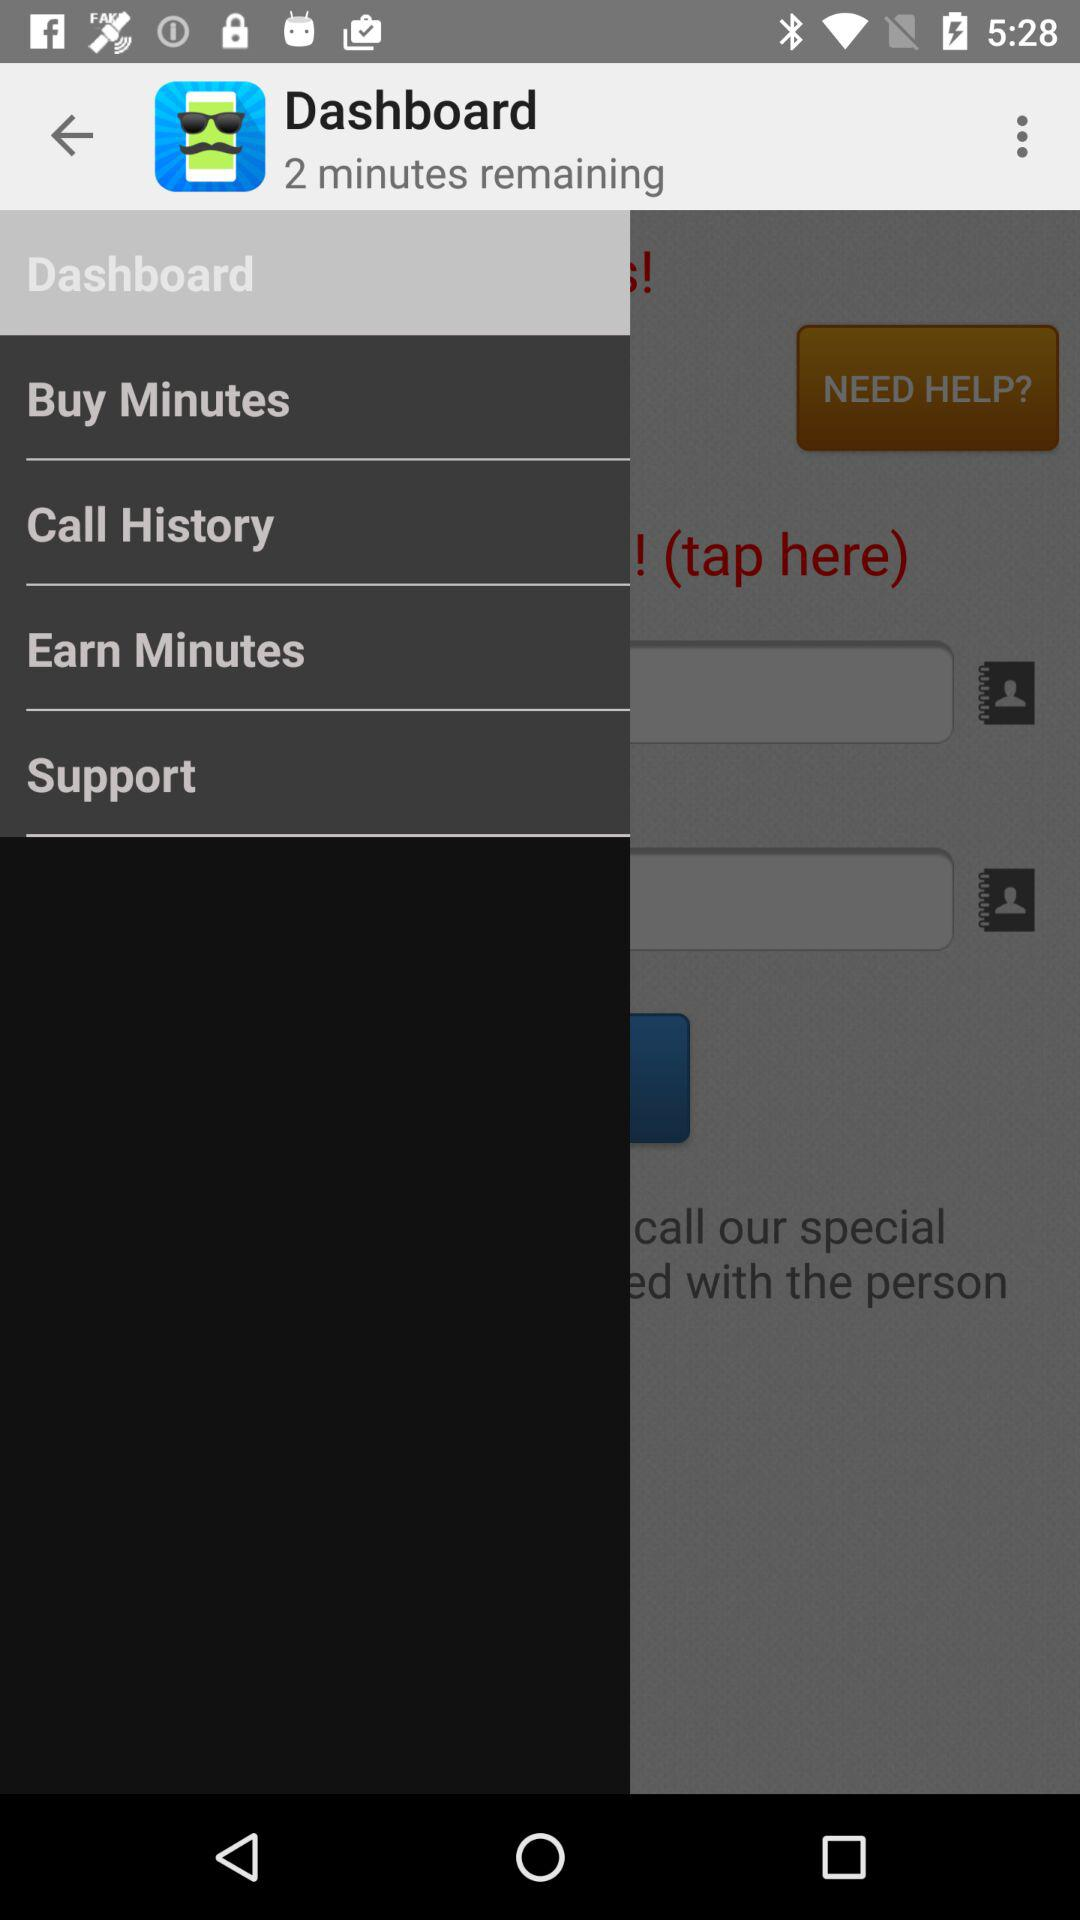What is the remaining time? The remaining time is 2 minutes. 